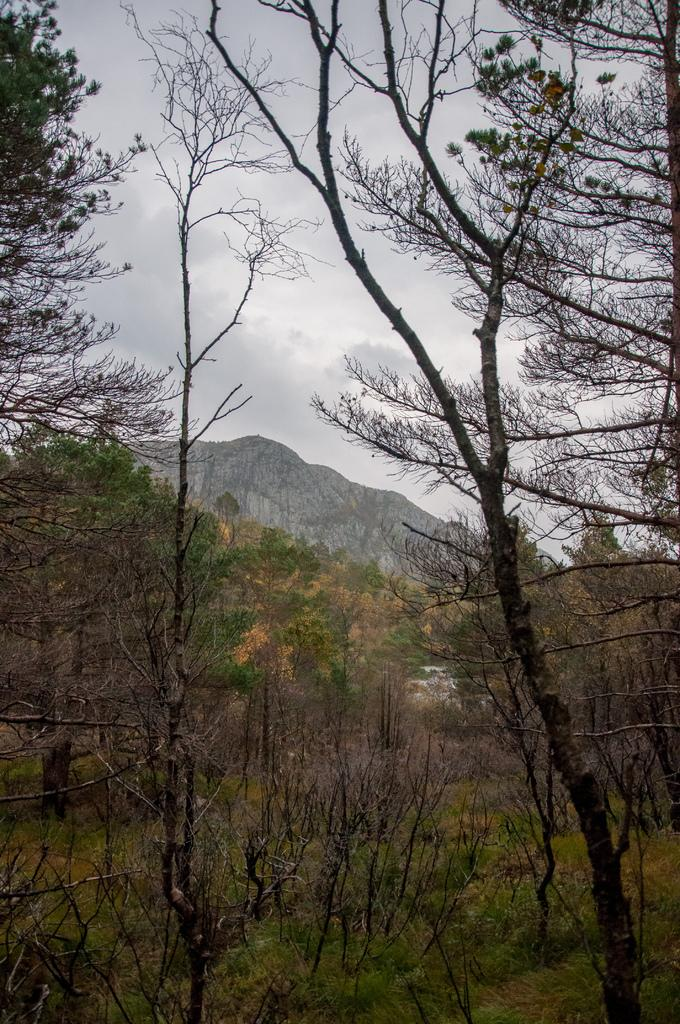What type of vegetation can be seen in the image? There is grass and trees in the image. What type of natural landform is visible in the image? There are mountains in the image. What part of the natural environment is visible in the image? The sky is visible in the image. Where might this image have been taken? The image may have been taken in a forest, given the presence of trees and grass. What color is the orange hanging from the tree in the image? There is no orange present in the image; it features grass, trees, mountains, and the sky. 